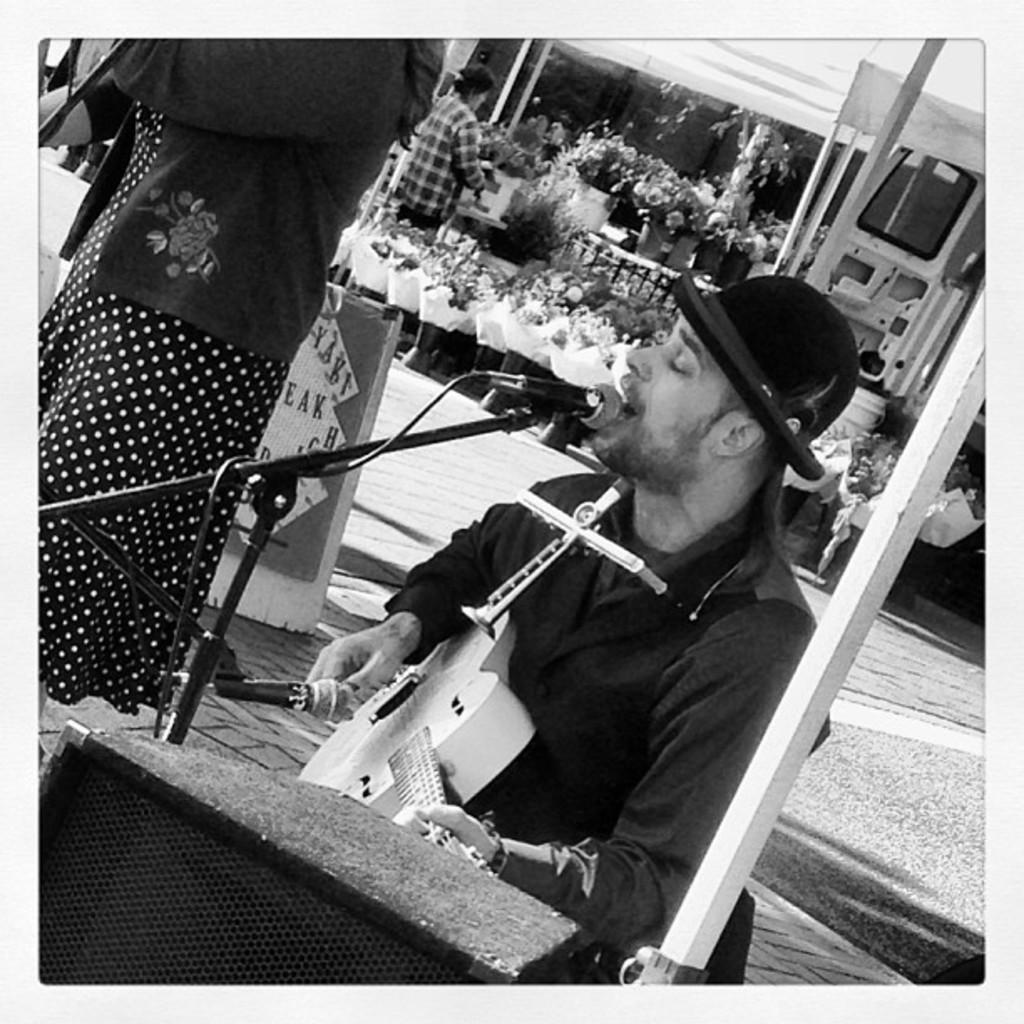Please provide a concise description of this image. This picture shows a man singing with the help of a microphone and playing a guitar and he wore a cap on his head and we see a woman standing on the side and we see few people standing on their back and we see plants around 